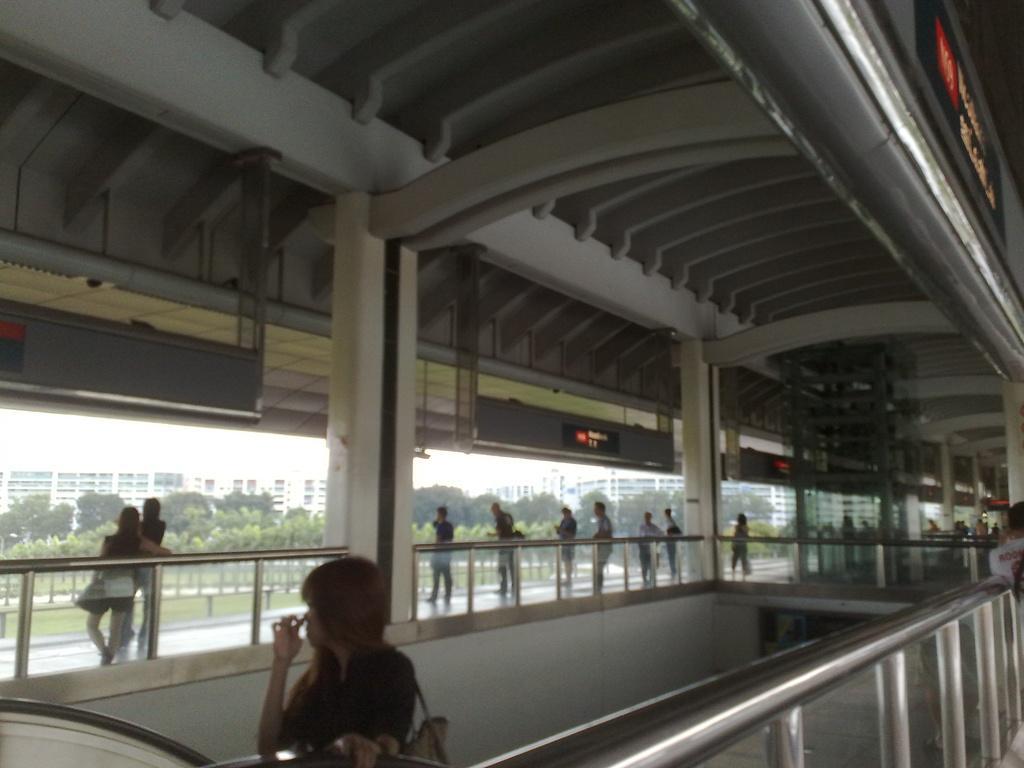Please provide a concise description of this image. This image consists of many people. In the front, there is a woman wearing a handbag. At the bottom, we can see a handrail. At the top, there is a shed and there are digital screens. In the background, we can see many trees and buildings. 